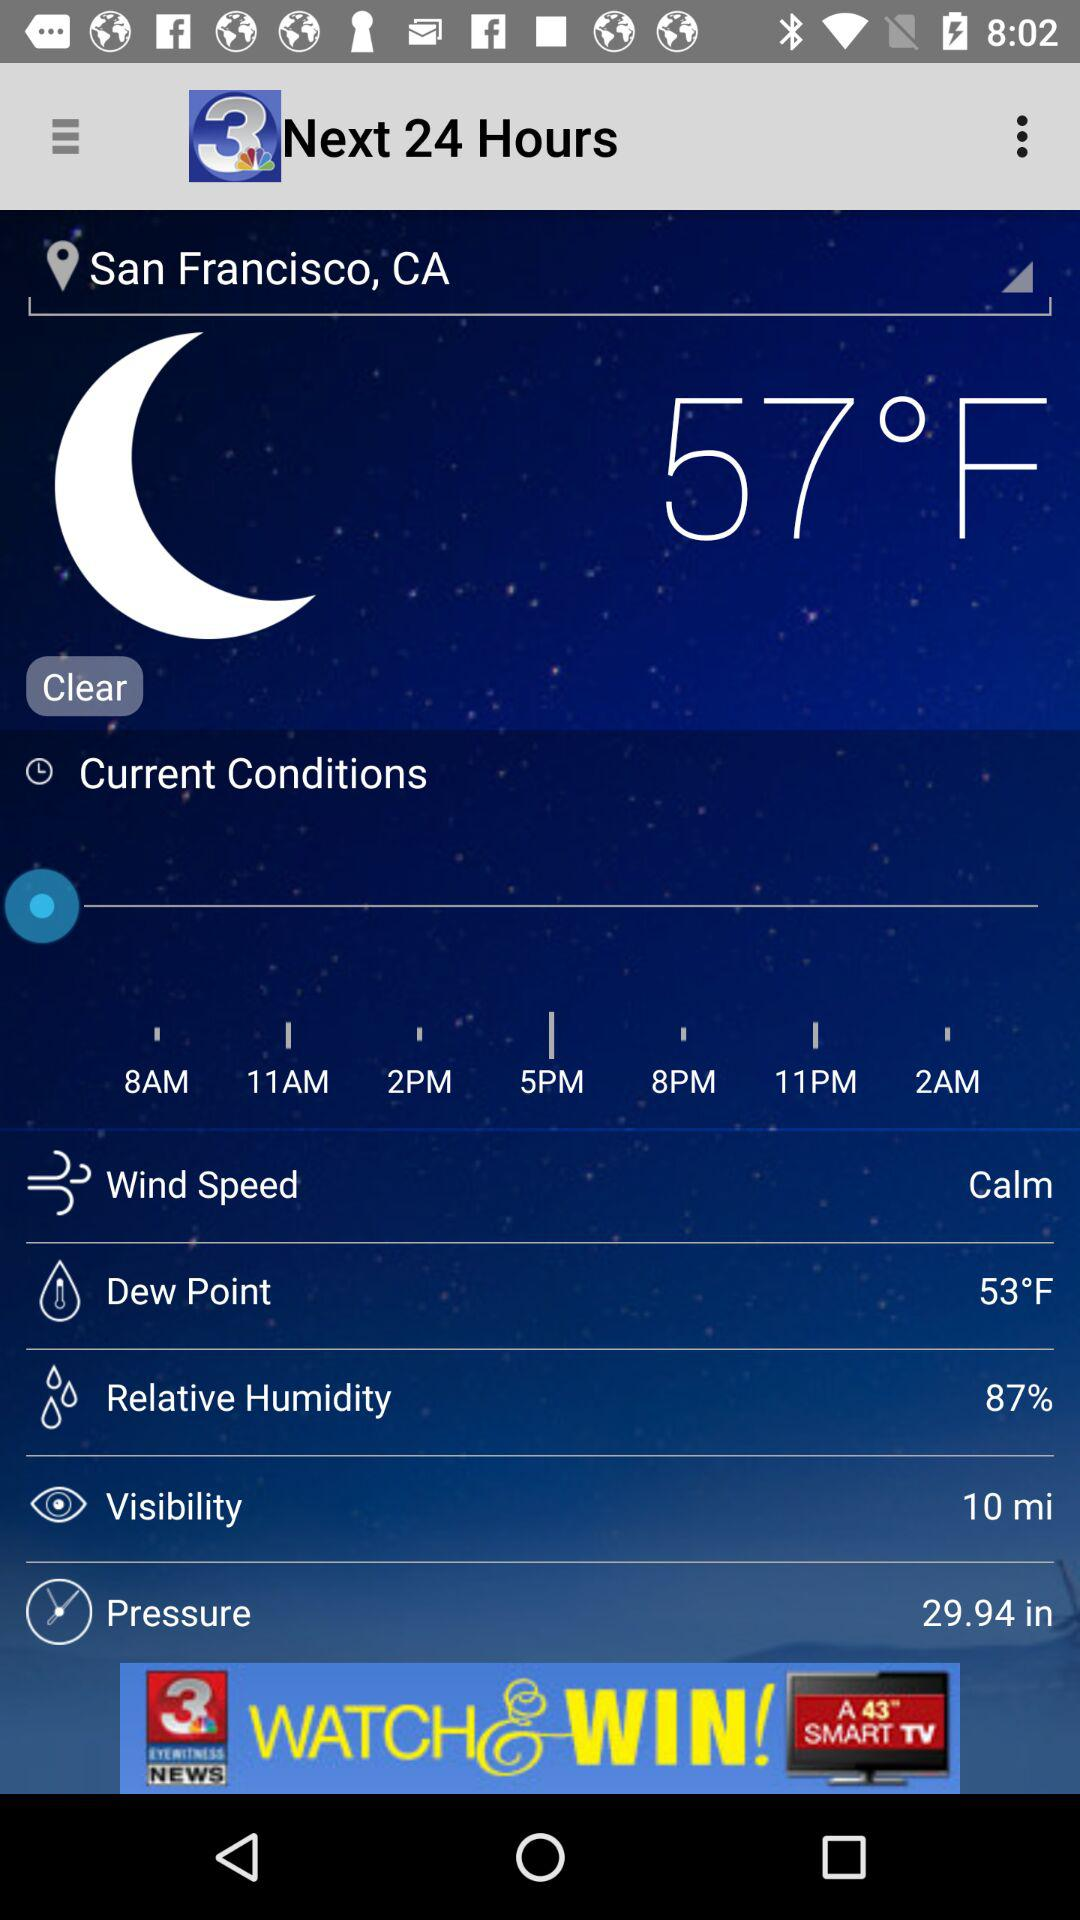What is the dew point? The dew point is 53 °F. 